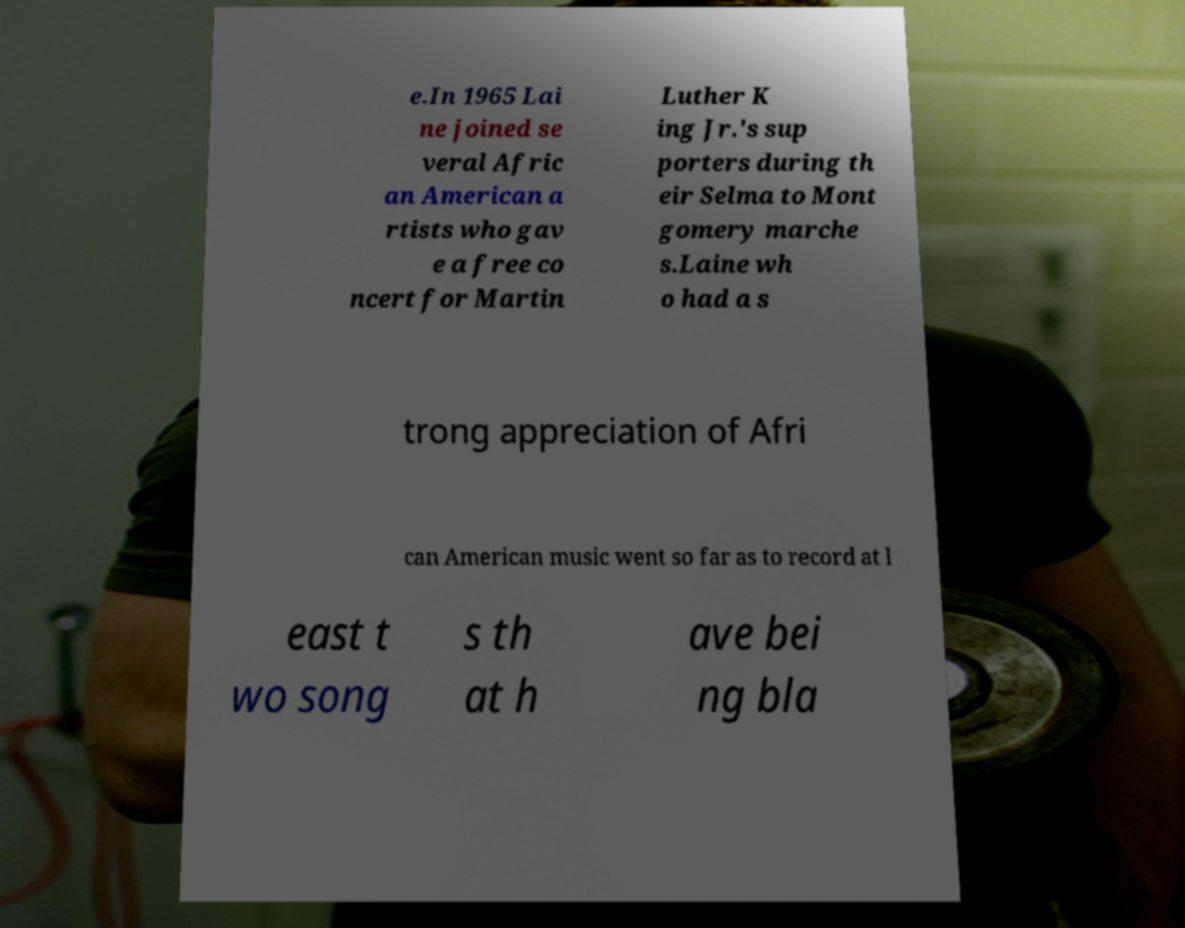For documentation purposes, I need the text within this image transcribed. Could you provide that? e.In 1965 Lai ne joined se veral Afric an American a rtists who gav e a free co ncert for Martin Luther K ing Jr.'s sup porters during th eir Selma to Mont gomery marche s.Laine wh o had a s trong appreciation of Afri can American music went so far as to record at l east t wo song s th at h ave bei ng bla 